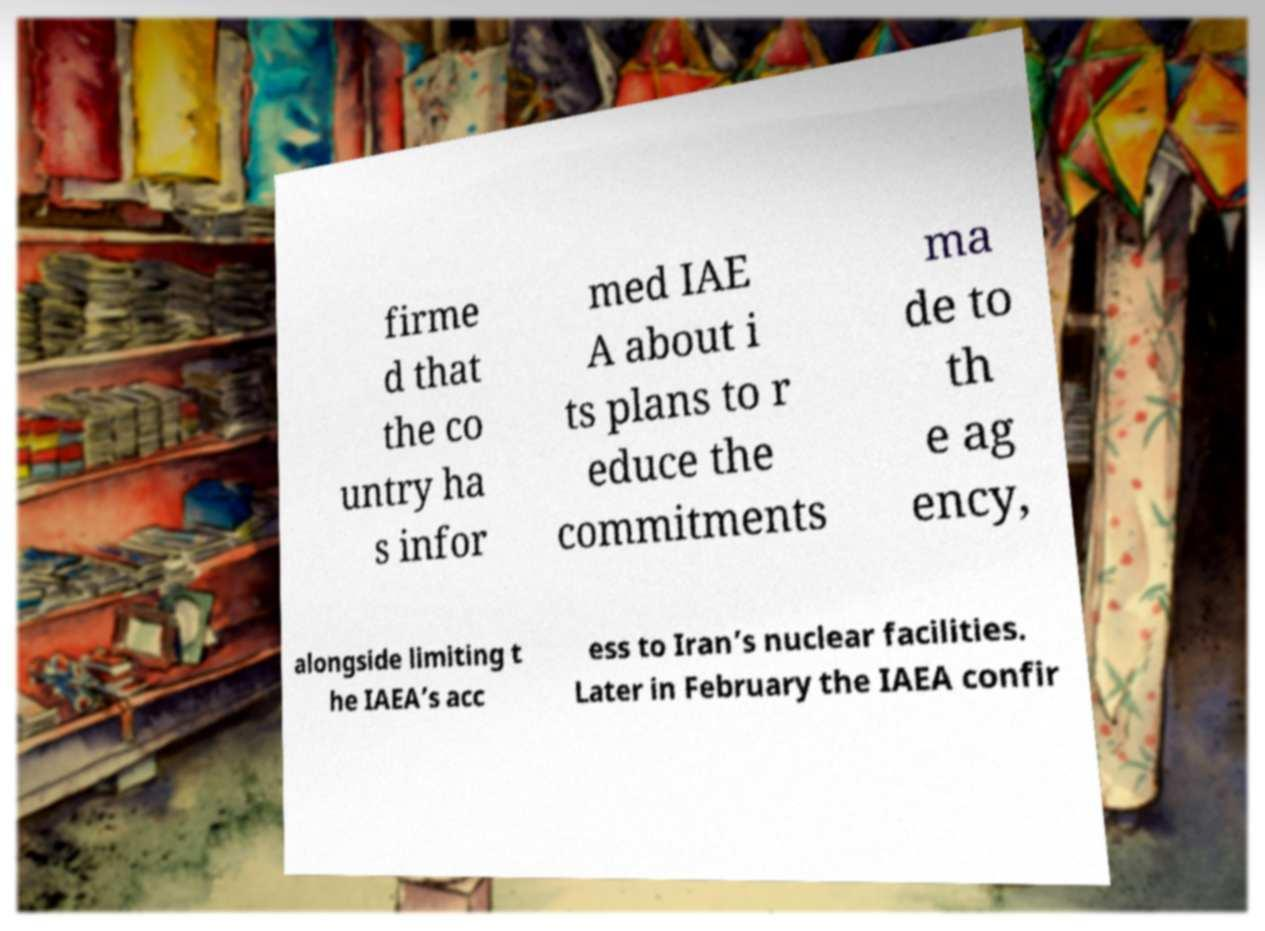Could you extract and type out the text from this image? firme d that the co untry ha s infor med IAE A about i ts plans to r educe the commitments ma de to th e ag ency, alongside limiting t he IAEA’s acc ess to Iran’s nuclear facilities. Later in February the IAEA confir 